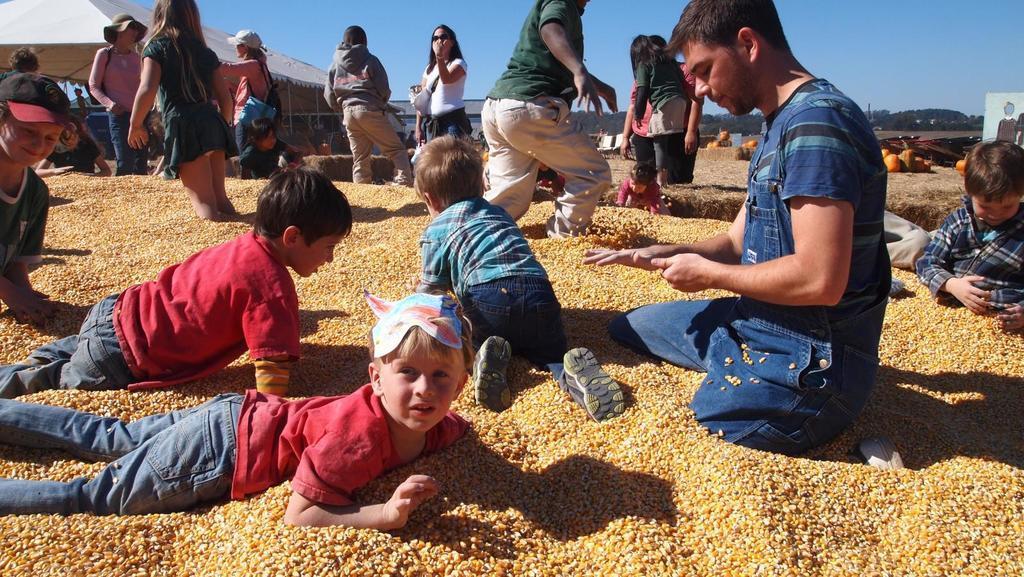Can you describe this image briefly? In the image there are few kids standing and laying on the floor covered with corn seeds all over it and in the back there are few women standing on it, over the background there are pumpkins on the land and a tent on the left side and above its sky. 